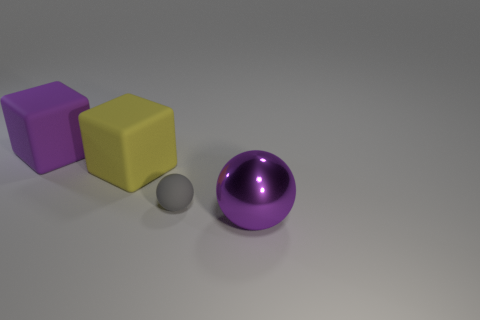Is the large cube that is in front of the purple block made of the same material as the small gray ball?
Ensure brevity in your answer.  Yes. Are there fewer purple cubes that are in front of the large yellow rubber object than big purple matte objects?
Your response must be concise. Yes. The big purple object right of the yellow block has what shape?
Your response must be concise. Sphere. What is the shape of the metallic object that is the same size as the yellow block?
Provide a succinct answer. Sphere. Is there a large metallic thing of the same shape as the small thing?
Keep it short and to the point. Yes. Do the purple object that is behind the purple metallic sphere and the yellow thing behind the tiny gray thing have the same shape?
Offer a very short reply. Yes. What material is the ball that is the same size as the yellow matte cube?
Provide a short and direct response. Metal. How many other objects are the same material as the large yellow block?
Make the answer very short. 2. The large purple object to the right of the purple object behind the purple ball is what shape?
Your response must be concise. Sphere. How many objects are purple spheres or objects that are to the left of the purple metallic object?
Your answer should be compact. 4. 